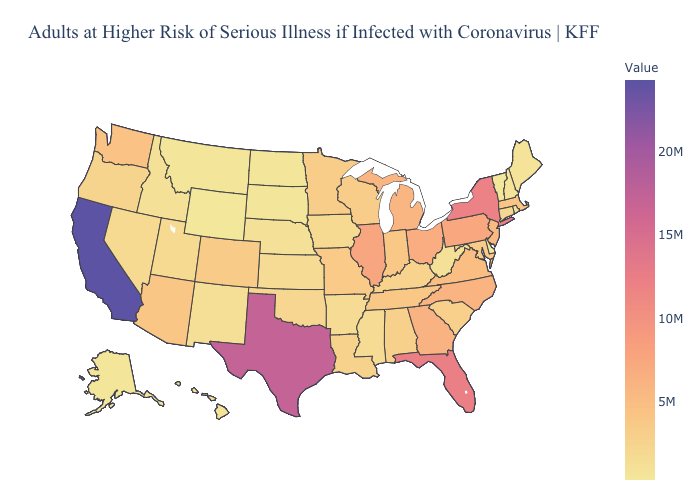Which states have the highest value in the USA?
Write a very short answer. California. Among the states that border Georgia , which have the highest value?
Be succinct. Florida. Which states hav the highest value in the MidWest?
Concise answer only. Illinois. Which states have the lowest value in the USA?
Concise answer only. Wyoming. Among the states that border Colorado , does Arizona have the lowest value?
Be succinct. No. Which states hav the highest value in the South?
Concise answer only. Texas. Is the legend a continuous bar?
Short answer required. Yes. 